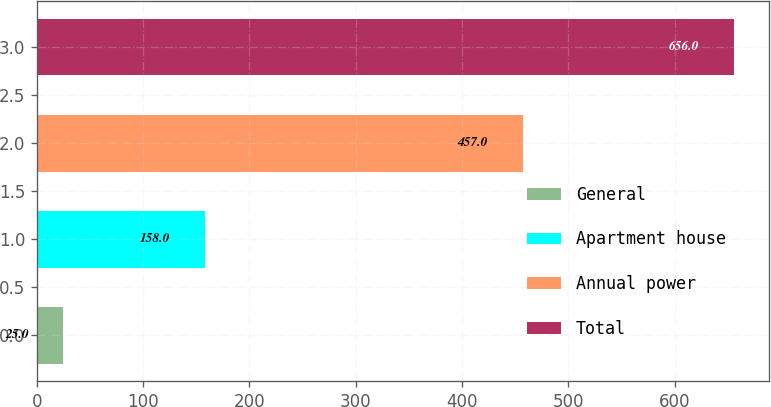<chart> <loc_0><loc_0><loc_500><loc_500><bar_chart><fcel>General<fcel>Apartment house<fcel>Annual power<fcel>Total<nl><fcel>25<fcel>158<fcel>457<fcel>656<nl></chart> 